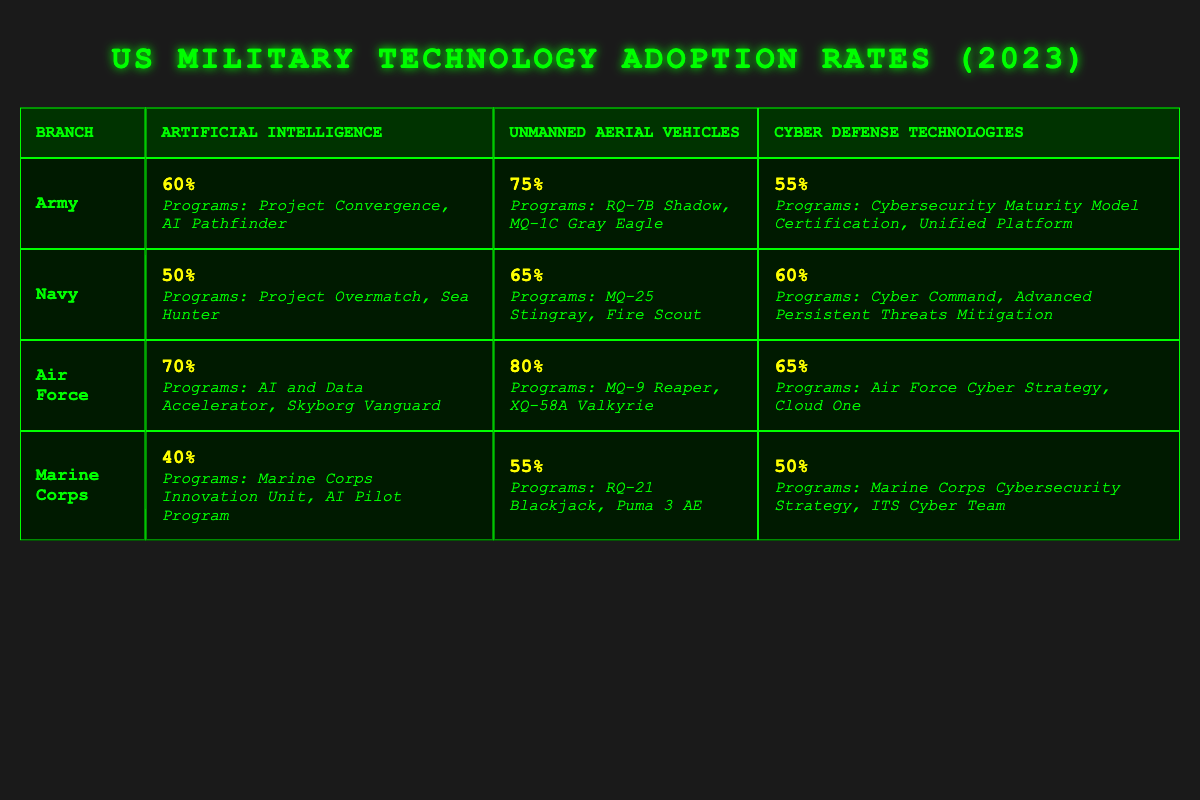What is the adoption rate of Artificial Intelligence by the Air Force? According to the table, the Air Force has an adoption rate of 70% for Artificial Intelligence.
Answer: 70% Which branch has the highest adoption rate for Unmanned Aerial Vehicles? The Air Force has the highest adoption rate of 80% for Unmanned Aerial Vehicles, compared to the other branches listed.
Answer: Air Force What are the programs associated with the Navy's Cyber Defense Technologies? The Navy's Cyber Defense Technologies include the programs Cyber Command and Advanced Persistent Threats Mitigation.
Answer: Cyber Command, Advanced Persistent Threats Mitigation Is it true that the Marine Corps has an adoption rate of Cyber Defense Technologies greater than 50%? The Marine Corps has an adoption rate of 50% for Cyber Defense Technologies, which is not greater than 50%.
Answer: No What is the difference in adoption rates for Artificial Intelligence between the Army and the Marine Corps? The Army has an adoption rate of 60% while the Marine Corps has 40%. The difference is 60% - 40% = 20%.
Answer: 20% Which branch has the lowest adoption rate for Unmanned Aerial Vehicles and what is that rate? The Marine Corps has the lowest adoption rate for Unmanned Aerial Vehicles at 55%.
Answer: Marine Corps, 55% What is the average adoption rate for Artificial Intelligence across all branches? The adoption rates are 60% (Army), 50% (Navy), 70% (Air Force), and 40% (Marine Corps). Summing these gives 60% + 50% + 70% + 40% = 220%, dividing by 4 gives an average of 220% / 4 = 55%.
Answer: 55% Which program is related to the Army's Unmanned Aerial Vehicles adoption? The programs related to the Army's Unmanned Aerial Vehicles are RQ-7B Shadow and MQ-1C Gray Eagle.
Answer: RQ-7B Shadow, MQ-1C Gray Eagle What is the relationship between the adoption rates of Artificial Intelligence and Cyber Defense Technologies for the Air Force? The Air Force has an adoption rate of 70% for Artificial Intelligence and 65% for Cyber Defense Technologies, indicating a higher adoption rate for AI by 5%.
Answer: Higher by 5% Does the Navy have a higher or lower adoption rate for Cyber Defense Technologies compared to the Army? The Navy's adoption rate is 60%, while the Army's is 55%, indicating that the Navy has a higher adoption rate for Cyber Defense Technologies.
Answer: Higher 